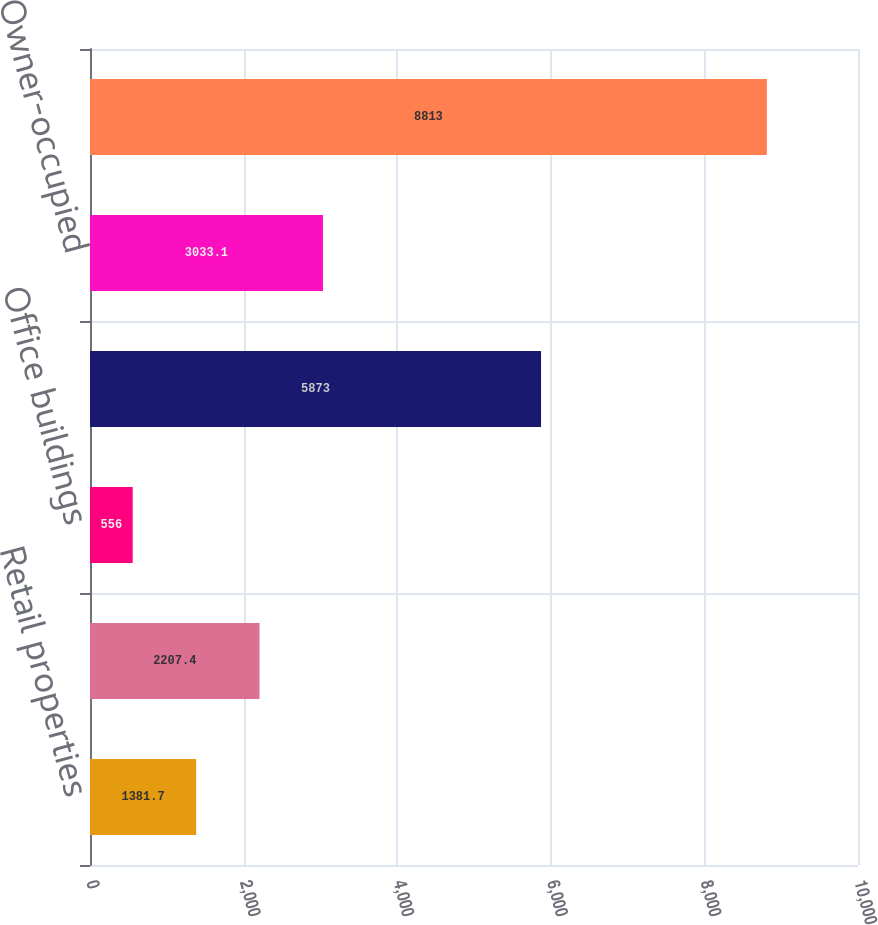Convert chart. <chart><loc_0><loc_0><loc_500><loc_500><bar_chart><fcel>Retail properties<fcel>Multifamily properties<fcel>Office buildings<fcel>Total nonowner-occupied<fcel>Owner-occupied<fcel>Total<nl><fcel>1381.7<fcel>2207.4<fcel>556<fcel>5873<fcel>3033.1<fcel>8813<nl></chart> 